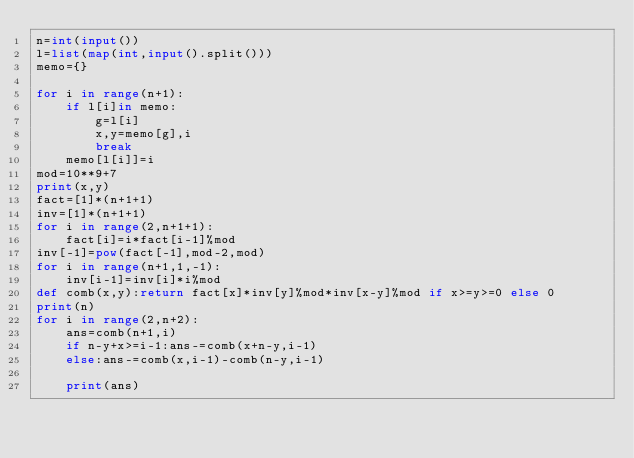Convert code to text. <code><loc_0><loc_0><loc_500><loc_500><_Python_>n=int(input())
l=list(map(int,input().split()))
memo={}

for i in range(n+1):
    if l[i]in memo:
        g=l[i]
        x,y=memo[g],i
        break
    memo[l[i]]=i
mod=10**9+7
print(x,y)
fact=[1]*(n+1+1)
inv=[1]*(n+1+1)
for i in range(2,n+1+1):
    fact[i]=i*fact[i-1]%mod
inv[-1]=pow(fact[-1],mod-2,mod)
for i in range(n+1,1,-1):
    inv[i-1]=inv[i]*i%mod
def comb(x,y):return fact[x]*inv[y]%mod*inv[x-y]%mod if x>=y>=0 else 0
print(n)
for i in range(2,n+2):
    ans=comb(n+1,i)
    if n-y+x>=i-1:ans-=comb(x+n-y,i-1)
    else:ans-=comb(x,i-1)-comb(n-y,i-1)
    
    print(ans)</code> 